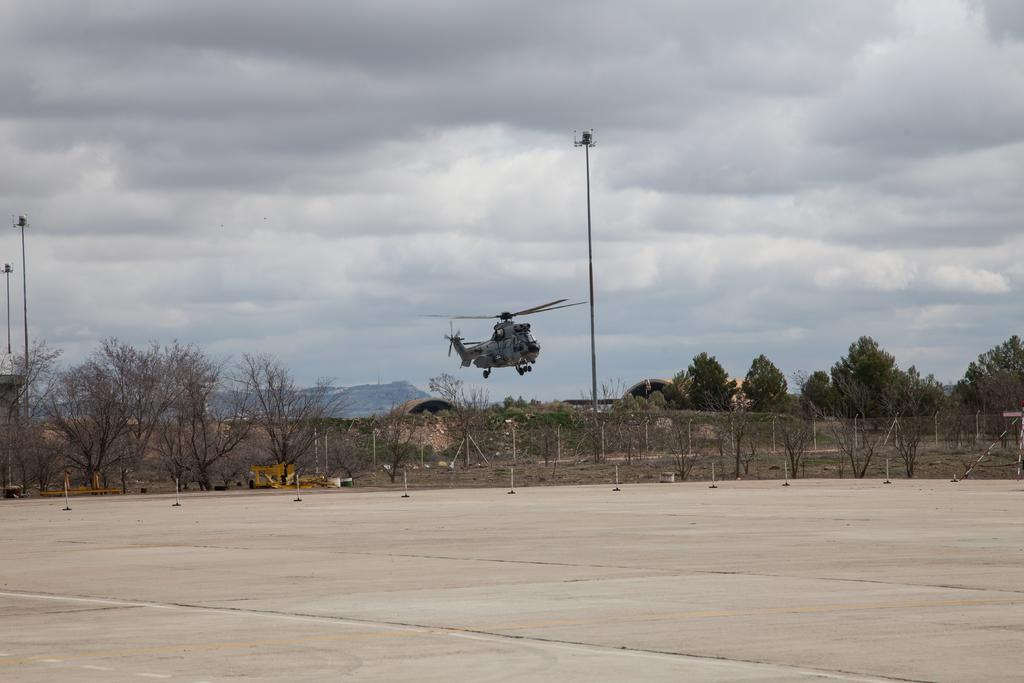What is visible on the ground in the image? The ground is visible in the image. What is flying in the sky in the image? There is a helicopter flying in the image. What type of vegetation can be seen in the image? Trees are present in the image. What structures can be seen in the image? Poles are visible in the image. What else can be seen in the image besides the helicopter and trees? There are objects in the image. What can be seen in the background of the image? Mountains and the sky are visible in the background of the image. How many apples are being held by the doll in the image? There is no doll or apples present in the image. What emotion is the doll experiencing in the image? There is no doll present in the image, so it is not possible to determine any emotions. 